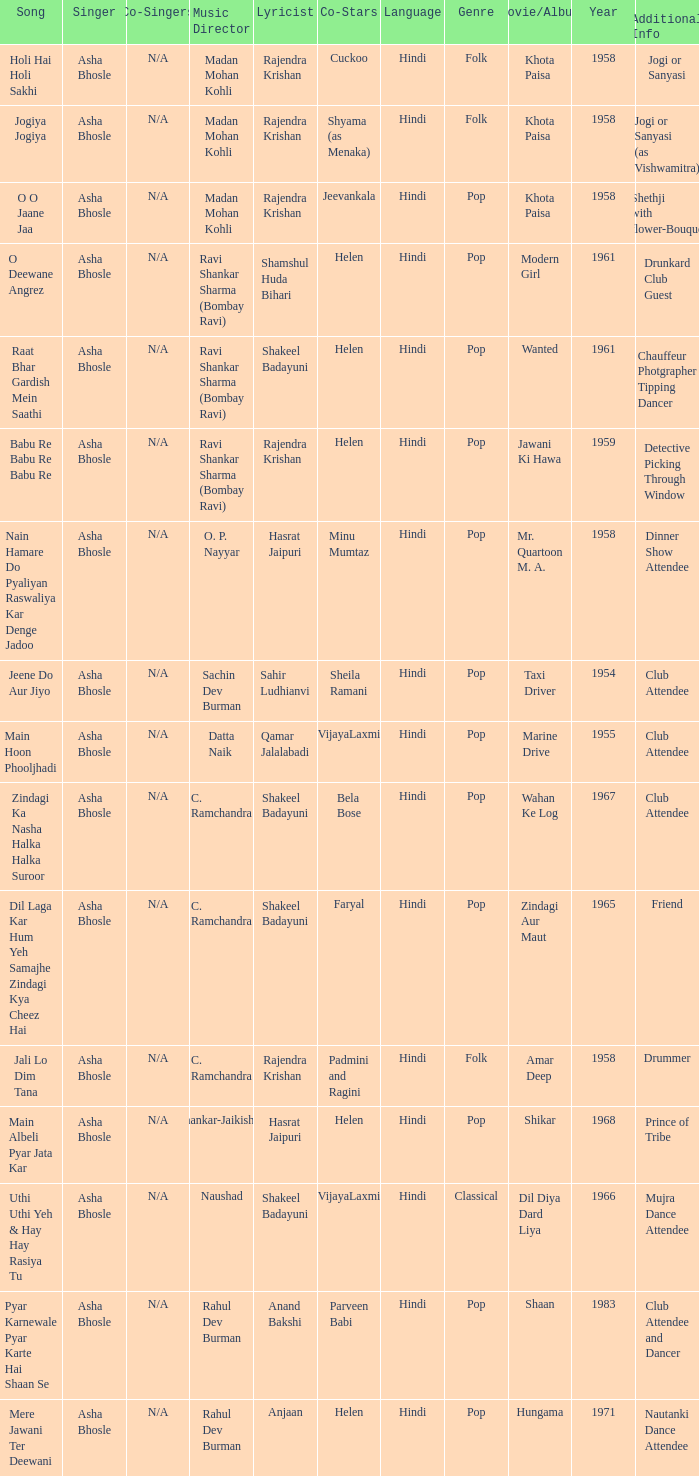How many co-singers were there when Parveen Babi co-starred? 1.0. 